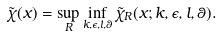<formula> <loc_0><loc_0><loc_500><loc_500>\tilde { \chi } ( x ) = \sup _ { R } \inf _ { k , \epsilon , l , \theta } \tilde { \chi } _ { R } ( x ; k , \epsilon , l , \theta ) .</formula> 